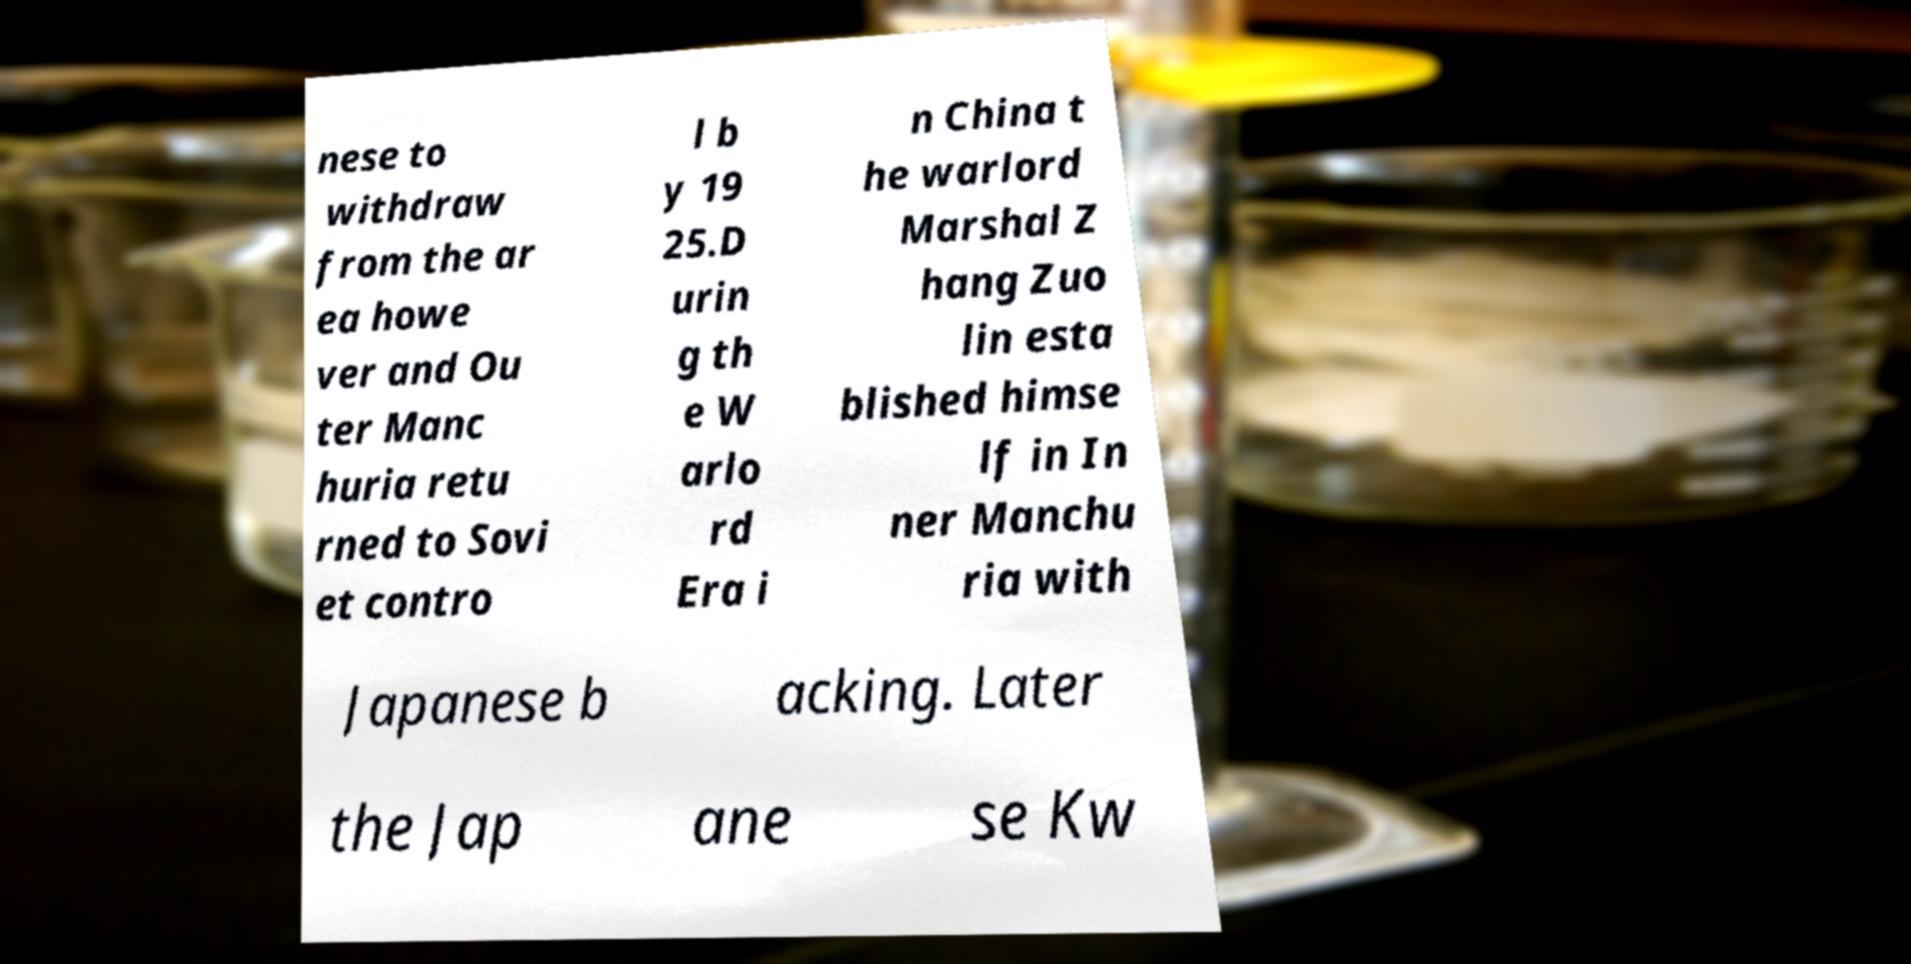Could you extract and type out the text from this image? nese to withdraw from the ar ea howe ver and Ou ter Manc huria retu rned to Sovi et contro l b y 19 25.D urin g th e W arlo rd Era i n China t he warlord Marshal Z hang Zuo lin esta blished himse lf in In ner Manchu ria with Japanese b acking. Later the Jap ane se Kw 